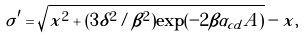<formula> <loc_0><loc_0><loc_500><loc_500>\sigma ^ { \prime } = \sqrt { x ^ { 2 } + ( 3 \delta ^ { 2 } / \beta ^ { 2 } ) \exp ( - 2 \beta \alpha _ { c d } A ) } - x ,</formula> 